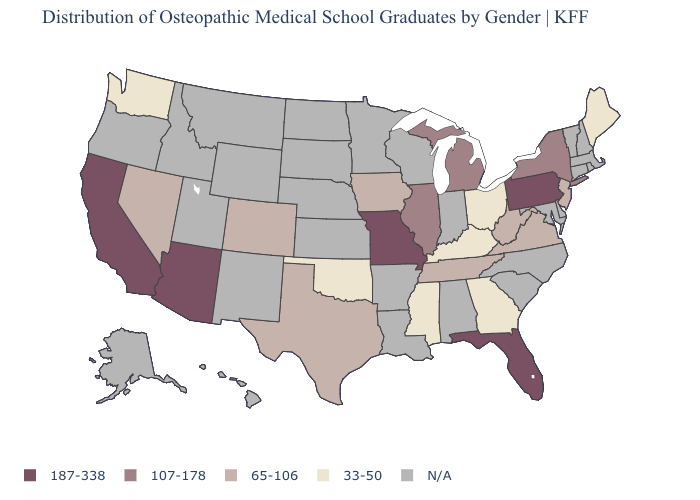Name the states that have a value in the range 107-178?
Keep it brief. Illinois, Michigan, New York. Name the states that have a value in the range 107-178?
Quick response, please. Illinois, Michigan, New York. Among the states that border Connecticut , which have the highest value?
Be succinct. New York. Name the states that have a value in the range 65-106?
Write a very short answer. Colorado, Iowa, Nevada, New Jersey, Tennessee, Texas, Virginia, West Virginia. What is the value of Texas?
Keep it brief. 65-106. What is the value of West Virginia?
Concise answer only. 65-106. Name the states that have a value in the range 107-178?
Give a very brief answer. Illinois, Michigan, New York. Which states hav the highest value in the West?
Quick response, please. Arizona, California. What is the value of Alabama?
Keep it brief. N/A. Among the states that border Florida , which have the highest value?
Give a very brief answer. Georgia. Does Washington have the highest value in the USA?
Be succinct. No. Name the states that have a value in the range 107-178?
Short answer required. Illinois, Michigan, New York. What is the value of Hawaii?
Short answer required. N/A. Which states have the highest value in the USA?
Short answer required. Arizona, California, Florida, Missouri, Pennsylvania. 